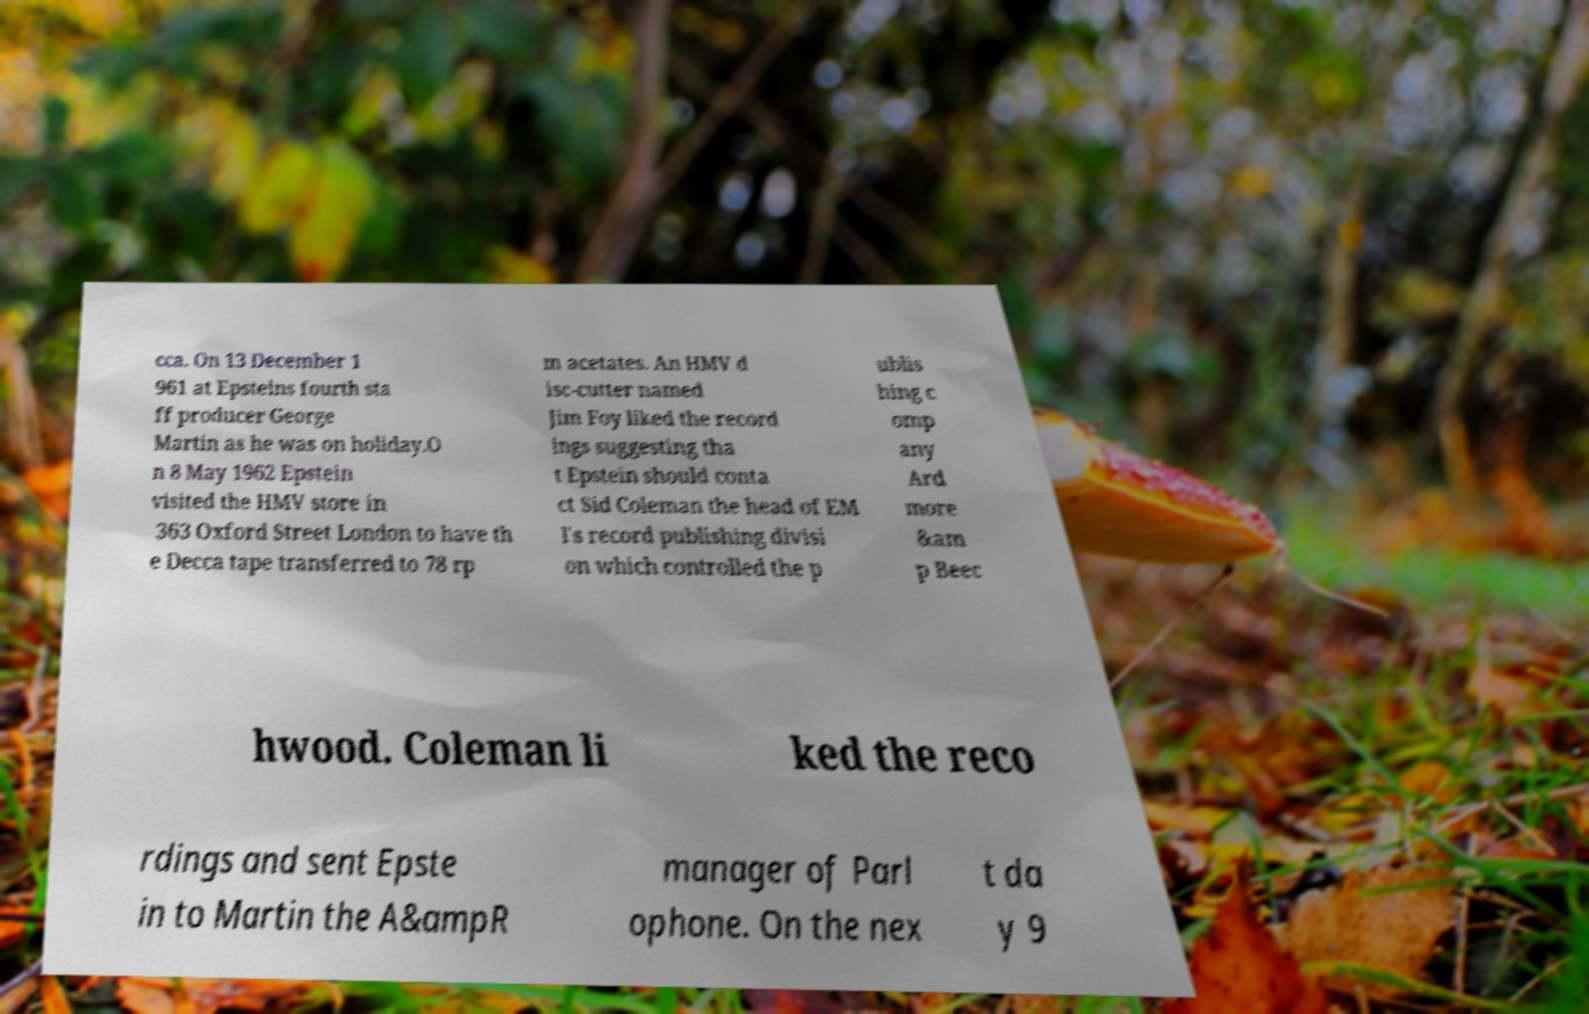Please read and relay the text visible in this image. What does it say? cca. On 13 December 1 961 at Epsteins fourth sta ff producer George Martin as he was on holiday.O n 8 May 1962 Epstein visited the HMV store in 363 Oxford Street London to have th e Decca tape transferred to 78 rp m acetates. An HMV d isc-cutter named Jim Foy liked the record ings suggesting tha t Epstein should conta ct Sid Coleman the head of EM I's record publishing divisi on which controlled the p ublis hing c omp any Ard more &am p Beec hwood. Coleman li ked the reco rdings and sent Epste in to Martin the A&ampR manager of Parl ophone. On the nex t da y 9 